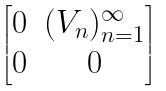<formula> <loc_0><loc_0><loc_500><loc_500>\begin{bmatrix} 0 & ( V _ { n } ) _ { n = 1 } ^ { \infty } \\ 0 & 0 \end{bmatrix}</formula> 